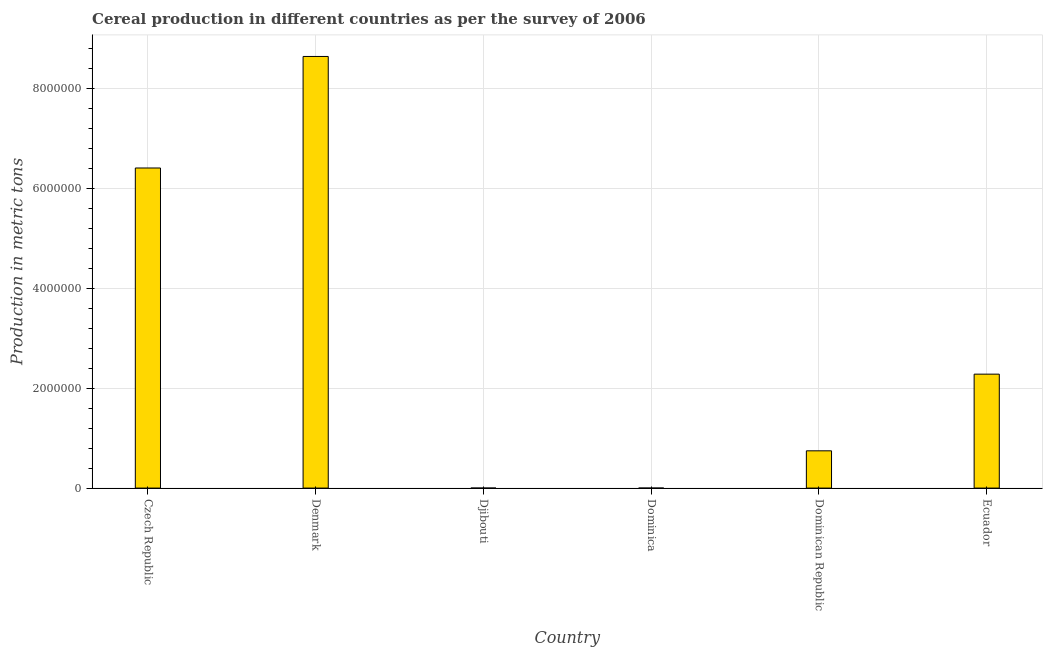Does the graph contain any zero values?
Ensure brevity in your answer.  No. What is the title of the graph?
Offer a very short reply. Cereal production in different countries as per the survey of 2006. What is the label or title of the Y-axis?
Make the answer very short. Production in metric tons. What is the cereal production in Czech Republic?
Make the answer very short. 6.40e+06. Across all countries, what is the maximum cereal production?
Ensure brevity in your answer.  8.63e+06. In which country was the cereal production maximum?
Make the answer very short. Denmark. In which country was the cereal production minimum?
Offer a terse response. Djibouti. What is the sum of the cereal production?
Offer a very short reply. 1.81e+07. What is the difference between the cereal production in Denmark and Dominican Republic?
Ensure brevity in your answer.  7.89e+06. What is the average cereal production per country?
Make the answer very short. 3.01e+06. What is the median cereal production?
Give a very brief answer. 1.51e+06. In how many countries, is the cereal production greater than 400000 metric tons?
Make the answer very short. 4. What is the ratio of the cereal production in Denmark to that in Ecuador?
Ensure brevity in your answer.  3.79. Is the difference between the cereal production in Czech Republic and Denmark greater than the difference between any two countries?
Your answer should be compact. No. What is the difference between the highest and the second highest cereal production?
Offer a terse response. 2.23e+06. What is the difference between the highest and the lowest cereal production?
Keep it short and to the point. 8.63e+06. In how many countries, is the cereal production greater than the average cereal production taken over all countries?
Provide a succinct answer. 2. How many bars are there?
Give a very brief answer. 6. Are all the bars in the graph horizontal?
Your answer should be compact. No. What is the difference between two consecutive major ticks on the Y-axis?
Your response must be concise. 2.00e+06. Are the values on the major ticks of Y-axis written in scientific E-notation?
Your answer should be compact. No. What is the Production in metric tons in Czech Republic?
Provide a succinct answer. 6.40e+06. What is the Production in metric tons of Denmark?
Your response must be concise. 8.63e+06. What is the Production in metric tons of Dominica?
Offer a terse response. 200. What is the Production in metric tons in Dominican Republic?
Ensure brevity in your answer.  7.45e+05. What is the Production in metric tons in Ecuador?
Offer a terse response. 2.28e+06. What is the difference between the Production in metric tons in Czech Republic and Denmark?
Ensure brevity in your answer.  -2.23e+06. What is the difference between the Production in metric tons in Czech Republic and Djibouti?
Give a very brief answer. 6.40e+06. What is the difference between the Production in metric tons in Czech Republic and Dominica?
Ensure brevity in your answer.  6.40e+06. What is the difference between the Production in metric tons in Czech Republic and Dominican Republic?
Your response must be concise. 5.66e+06. What is the difference between the Production in metric tons in Czech Republic and Ecuador?
Offer a very short reply. 4.12e+06. What is the difference between the Production in metric tons in Denmark and Djibouti?
Ensure brevity in your answer.  8.63e+06. What is the difference between the Production in metric tons in Denmark and Dominica?
Keep it short and to the point. 8.63e+06. What is the difference between the Production in metric tons in Denmark and Dominican Republic?
Ensure brevity in your answer.  7.89e+06. What is the difference between the Production in metric tons in Denmark and Ecuador?
Provide a short and direct response. 6.35e+06. What is the difference between the Production in metric tons in Djibouti and Dominica?
Offer a very short reply. -190. What is the difference between the Production in metric tons in Djibouti and Dominican Republic?
Your answer should be very brief. -7.45e+05. What is the difference between the Production in metric tons in Djibouti and Ecuador?
Keep it short and to the point. -2.28e+06. What is the difference between the Production in metric tons in Dominica and Dominican Republic?
Give a very brief answer. -7.45e+05. What is the difference between the Production in metric tons in Dominica and Ecuador?
Your response must be concise. -2.28e+06. What is the difference between the Production in metric tons in Dominican Republic and Ecuador?
Your answer should be very brief. -1.53e+06. What is the ratio of the Production in metric tons in Czech Republic to that in Denmark?
Keep it short and to the point. 0.74. What is the ratio of the Production in metric tons in Czech Republic to that in Djibouti?
Your response must be concise. 6.40e+05. What is the ratio of the Production in metric tons in Czech Republic to that in Dominica?
Your answer should be very brief. 3.20e+04. What is the ratio of the Production in metric tons in Czech Republic to that in Dominican Republic?
Offer a terse response. 8.59. What is the ratio of the Production in metric tons in Czech Republic to that in Ecuador?
Offer a very short reply. 2.81. What is the ratio of the Production in metric tons in Denmark to that in Djibouti?
Provide a short and direct response. 8.63e+05. What is the ratio of the Production in metric tons in Denmark to that in Dominica?
Provide a succinct answer. 4.32e+04. What is the ratio of the Production in metric tons in Denmark to that in Dominican Republic?
Ensure brevity in your answer.  11.58. What is the ratio of the Production in metric tons in Denmark to that in Ecuador?
Provide a short and direct response. 3.79. What is the ratio of the Production in metric tons in Djibouti to that in Dominica?
Make the answer very short. 0.05. What is the ratio of the Production in metric tons in Dominica to that in Dominican Republic?
Your response must be concise. 0. What is the ratio of the Production in metric tons in Dominica to that in Ecuador?
Provide a succinct answer. 0. What is the ratio of the Production in metric tons in Dominican Republic to that in Ecuador?
Keep it short and to the point. 0.33. 